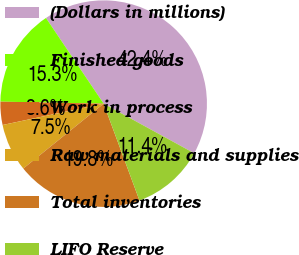<chart> <loc_0><loc_0><loc_500><loc_500><pie_chart><fcel>(Dollars in millions)<fcel>Finished goods<fcel>Work in process<fcel>Raw materials and supplies<fcel>Total inventories<fcel>LIFO Reserve<nl><fcel>42.41%<fcel>15.26%<fcel>3.62%<fcel>7.5%<fcel>19.83%<fcel>11.38%<nl></chart> 